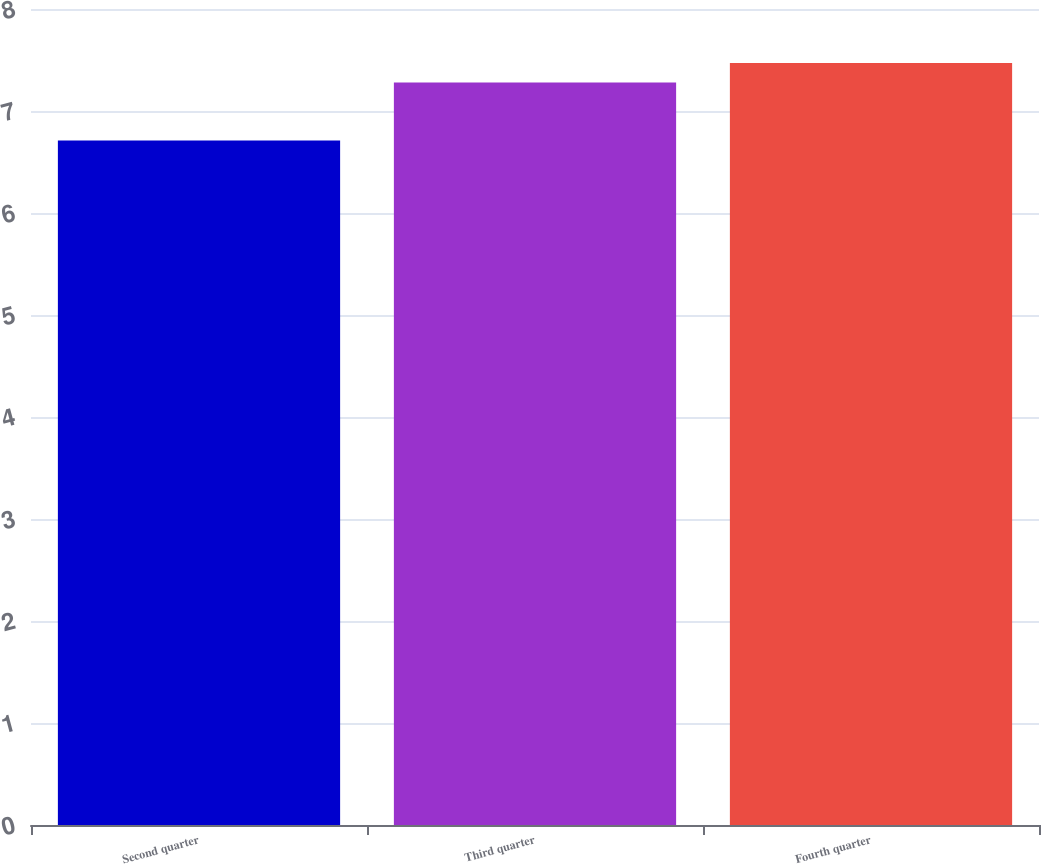Convert chart. <chart><loc_0><loc_0><loc_500><loc_500><bar_chart><fcel>Second quarter<fcel>Third quarter<fcel>Fourth quarter<nl><fcel>6.71<fcel>7.28<fcel>7.47<nl></chart> 